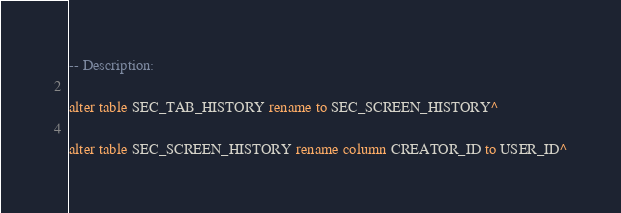<code> <loc_0><loc_0><loc_500><loc_500><_SQL_>-- Description:

alter table SEC_TAB_HISTORY rename to SEC_SCREEN_HISTORY^

alter table SEC_SCREEN_HISTORY rename column CREATOR_ID to USER_ID^</code> 